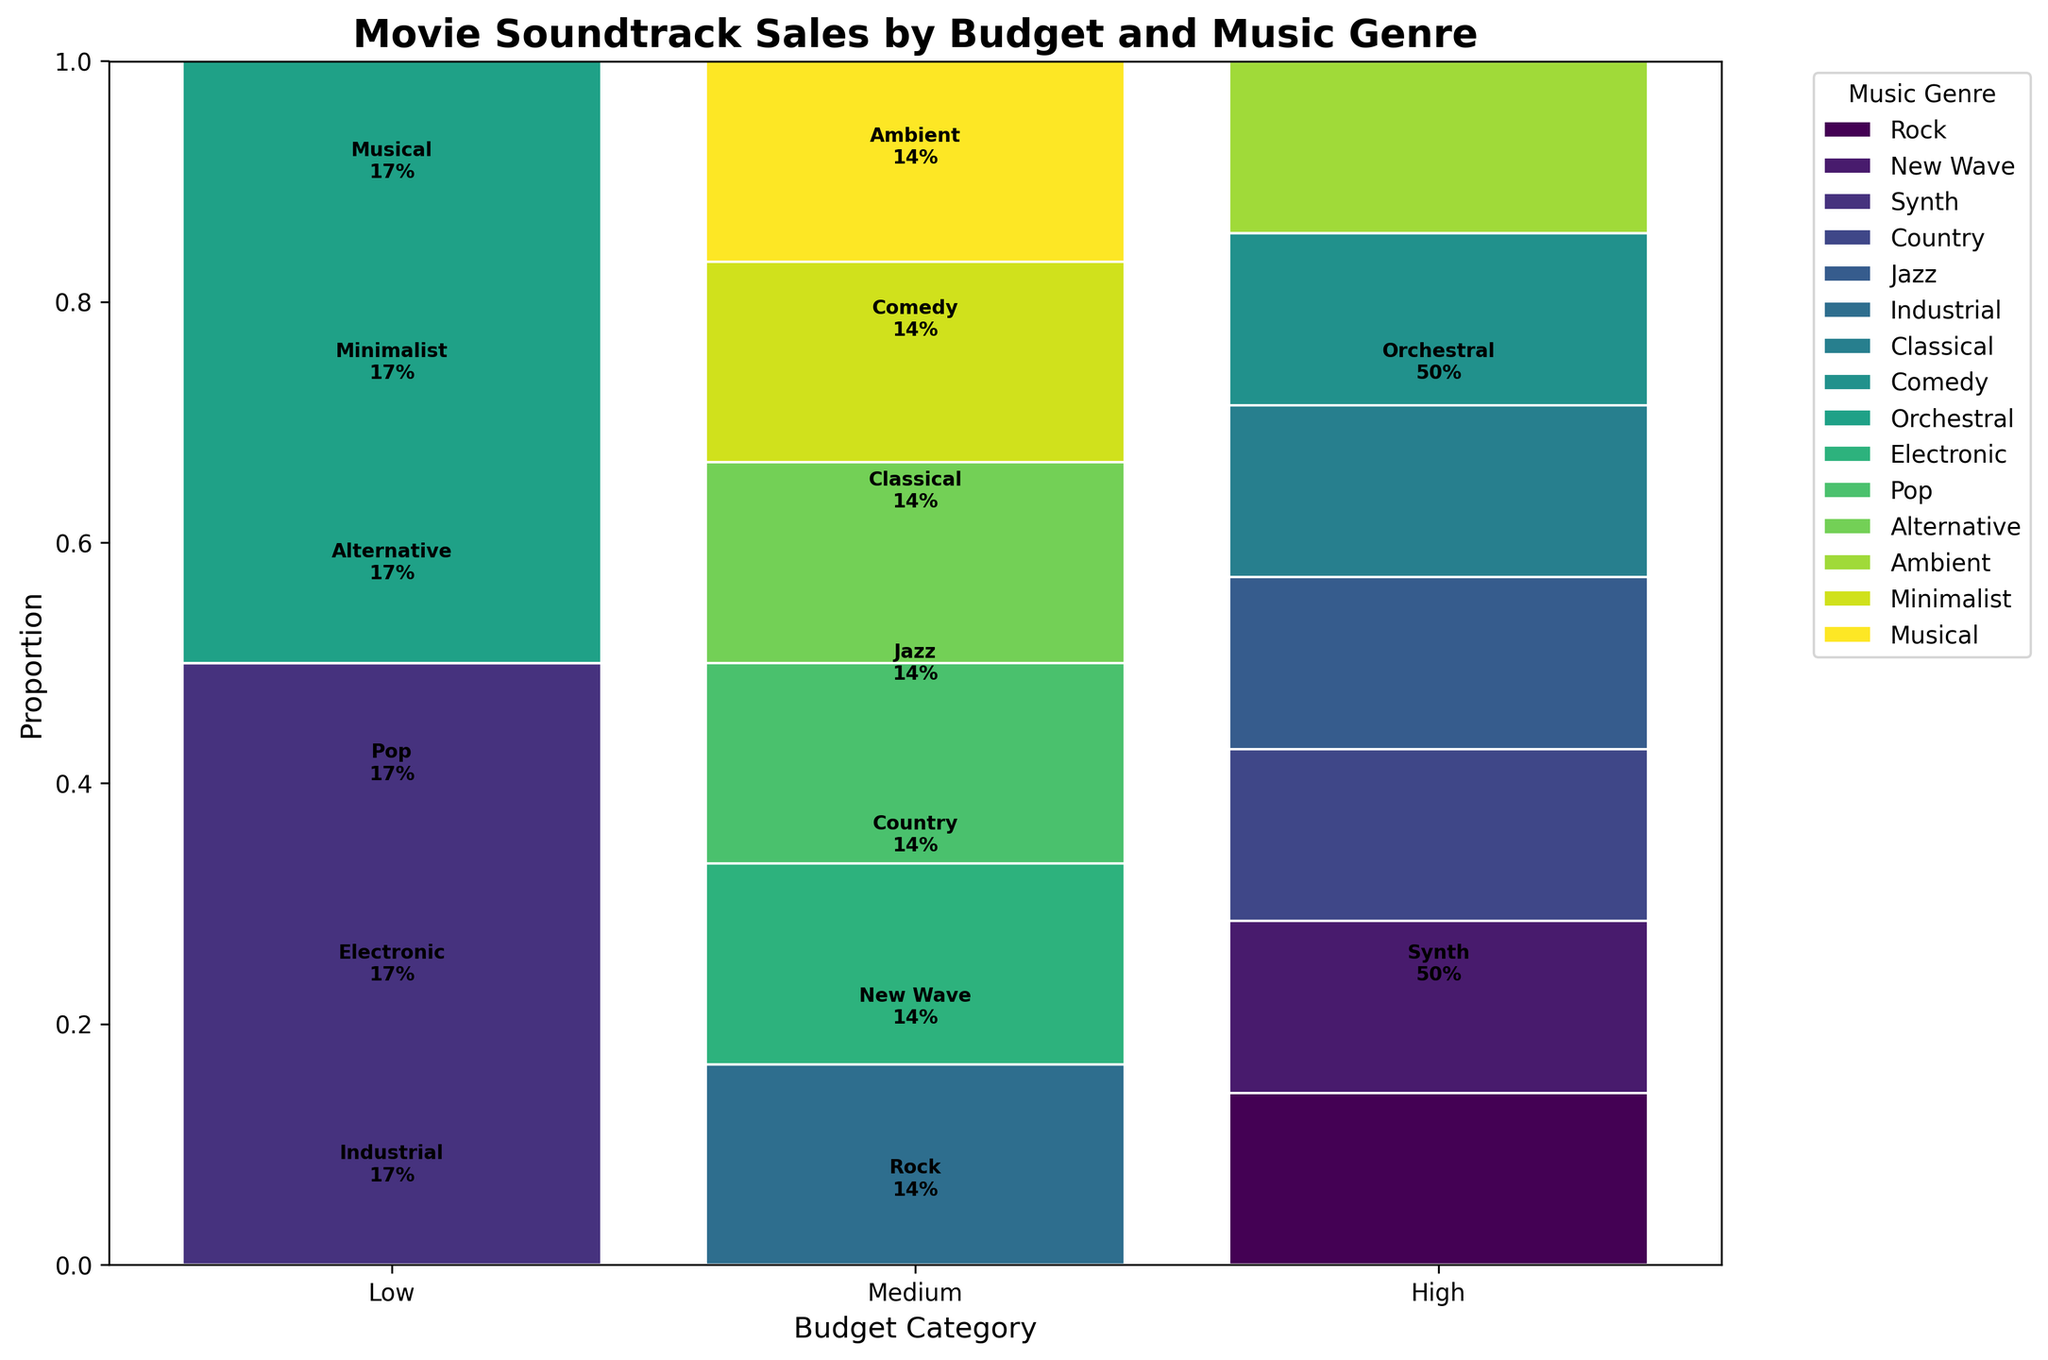Which music genre occupies the largest proportion in the low-budget category? In the mosaic plot, observe the low-budget category and compare the segments for each music genre. The genre with the largest segment is the one with the highest proportion.
Answer: Industrial What is the total proportion of rock and new wave music genres in the medium-budget category? First, find the proportions of rock and new wave music in the medium-budget category from the plot. Then sum these proportions to get the total.
Answer: 0.33 Which budget category has the highest variety of music genres represented? Examine all budget categories and count the different music genres represented by segments in each category. The one with the highest count has the highest variety.
Answer: Medium Is classical music represented in the high-budget category? Look at the segments in the high-budget category and check if classical music is one of them.
Answer: No Which music genre has the largest proportion across all budget categories? Identify the genres in each budget category and sum the proportions of each genre across all categories. The one with the highest sum is the largest.
Answer: Rock How do the proportions of comedy music in medium and high-budget categories compare? Look at the comedy segments in both medium and high-budget categories and compare their sizes. The category with the larger segment has the larger proportion.
Answer: High > Medium What proportion of the high-budget category is occupied by orchestral music? Locate the high-budget category and identify the segment for orchestral music. The size of this segment represents its proportion.
Answer: 0.33 How many music genres are there in the low-budget category? Count the distinct segments representing different music genres in the low-budget category.
Answer: 5 Which budget category has the smallest representation of alternative music? Check the segments for alternative music in all budget categories and identify the category with the smallest segment for alternative music.
Answer: High Does the medium-budget category have more representation of electronic or ambient music? Compare the segments for electronic and ambient music in the medium-budget category. The one with the larger segment has more representation.
Answer: Ambient 